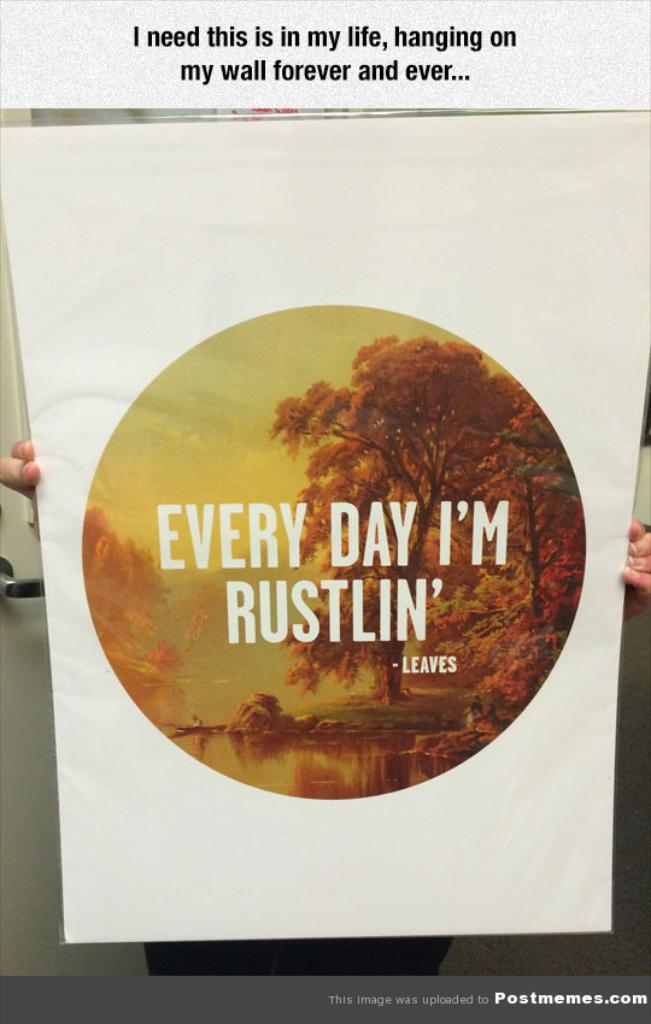<image>
Provide a brief description of the given image. Every day I'm rustling is a quote by leaves. 